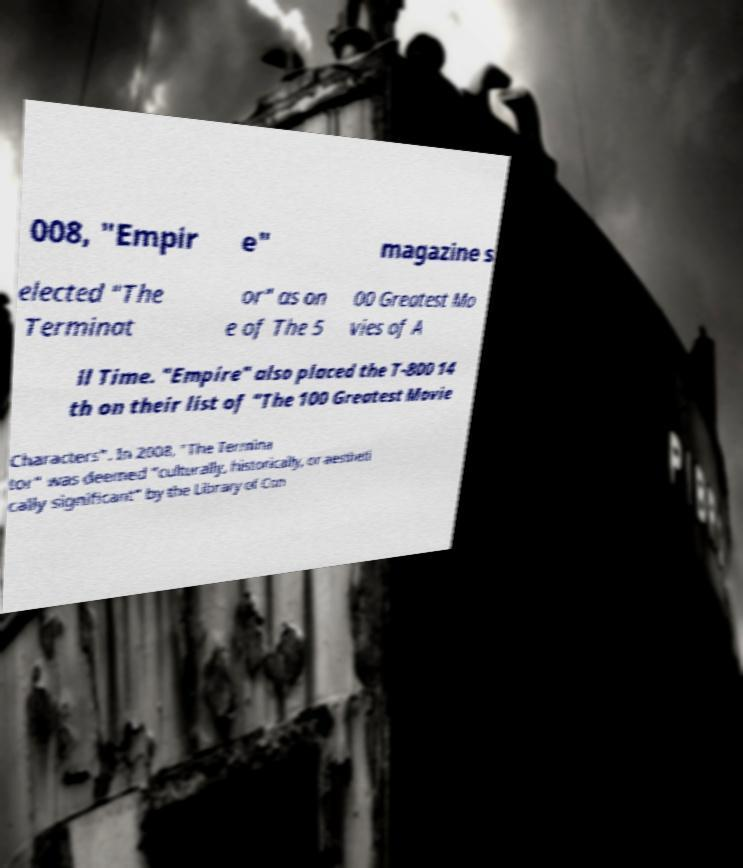Please read and relay the text visible in this image. What does it say? 008, "Empir e" magazine s elected "The Terminat or" as on e of The 5 00 Greatest Mo vies of A ll Time. "Empire" also placed the T-800 14 th on their list of "The 100 Greatest Movie Characters". In 2008, "The Termina tor" was deemed "culturally, historically, or aestheti cally significant" by the Library of Con 